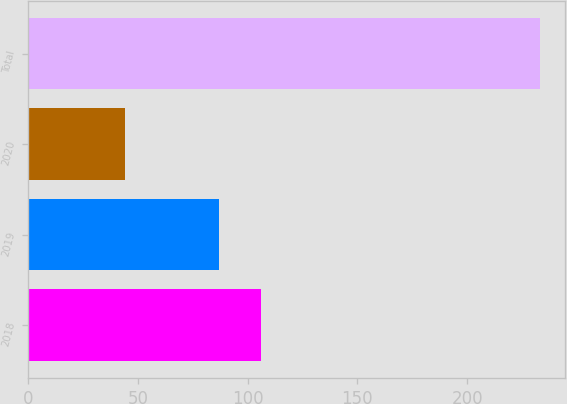Convert chart. <chart><loc_0><loc_0><loc_500><loc_500><bar_chart><fcel>2018<fcel>2019<fcel>2020<fcel>Total<nl><fcel>105.9<fcel>87<fcel>44<fcel>233<nl></chart> 